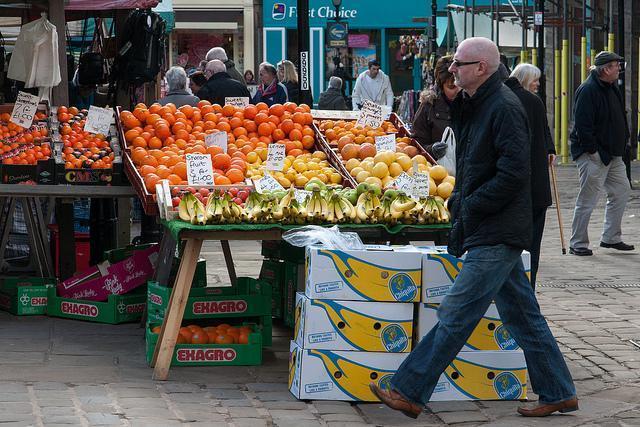How many different fruits can be seen?
Give a very brief answer. 4. How many green bananas are in this storefront?
Give a very brief answer. 0. How many watermelons are in this picture?
Give a very brief answer. 0. How many people are in front of the fruit stand?
Give a very brief answer. 1. How many oranges are in the picture?
Give a very brief answer. 2. How many people are in the photo?
Give a very brief answer. 4. How many giraffes are there?
Give a very brief answer. 0. 